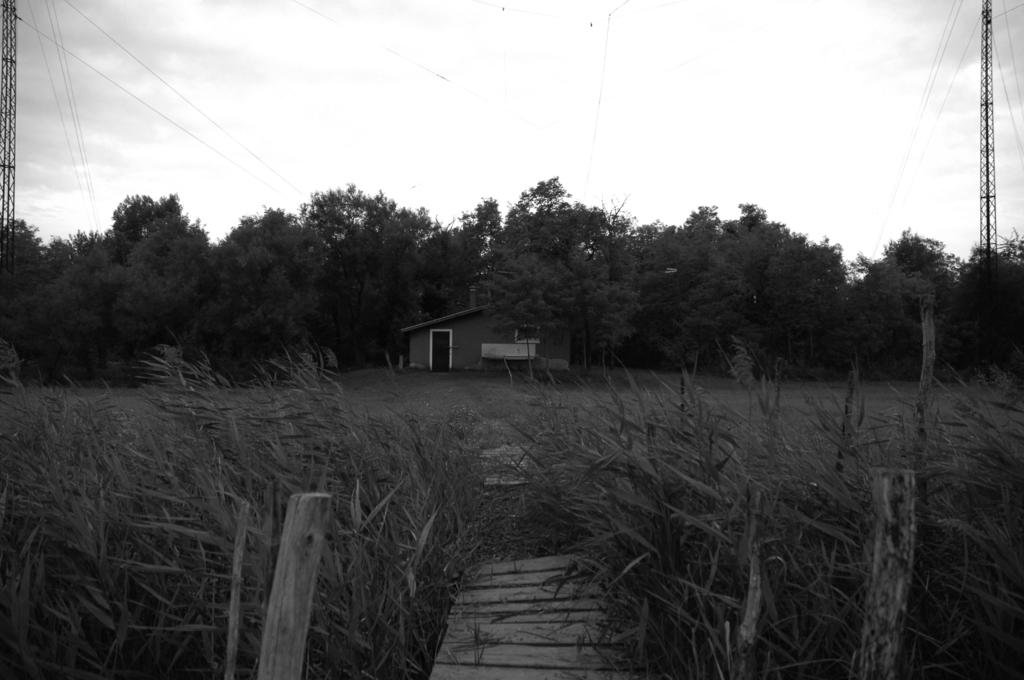What type of vegetation can be seen in the image? There are trees and plants in the image. What type of structure is present in the image? There is a house and towers in the image. Is there any architectural feature in the image that allows crossing over water or land? Yes, there is a small wooden bridge in the image. What can be seen in the sky in the image? The sky is cloudy in the image. What type of ticket is required to enter the government building in the image? There is no government building or ticket present in the image. What songs are being played by the musicians in the image? There are no musicians or songs present in the image. 